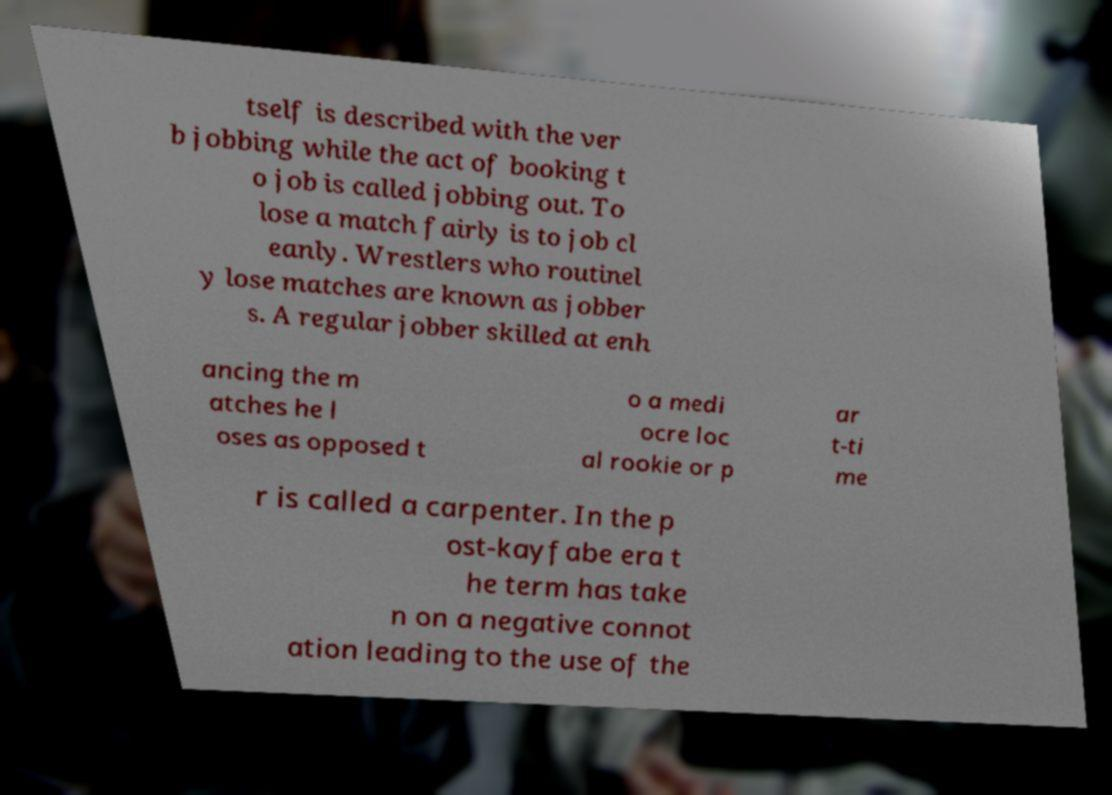I need the written content from this picture converted into text. Can you do that? tself is described with the ver b jobbing while the act of booking t o job is called jobbing out. To lose a match fairly is to job cl eanly. Wrestlers who routinel y lose matches are known as jobber s. A regular jobber skilled at enh ancing the m atches he l oses as opposed t o a medi ocre loc al rookie or p ar t-ti me r is called a carpenter. In the p ost-kayfabe era t he term has take n on a negative connot ation leading to the use of the 